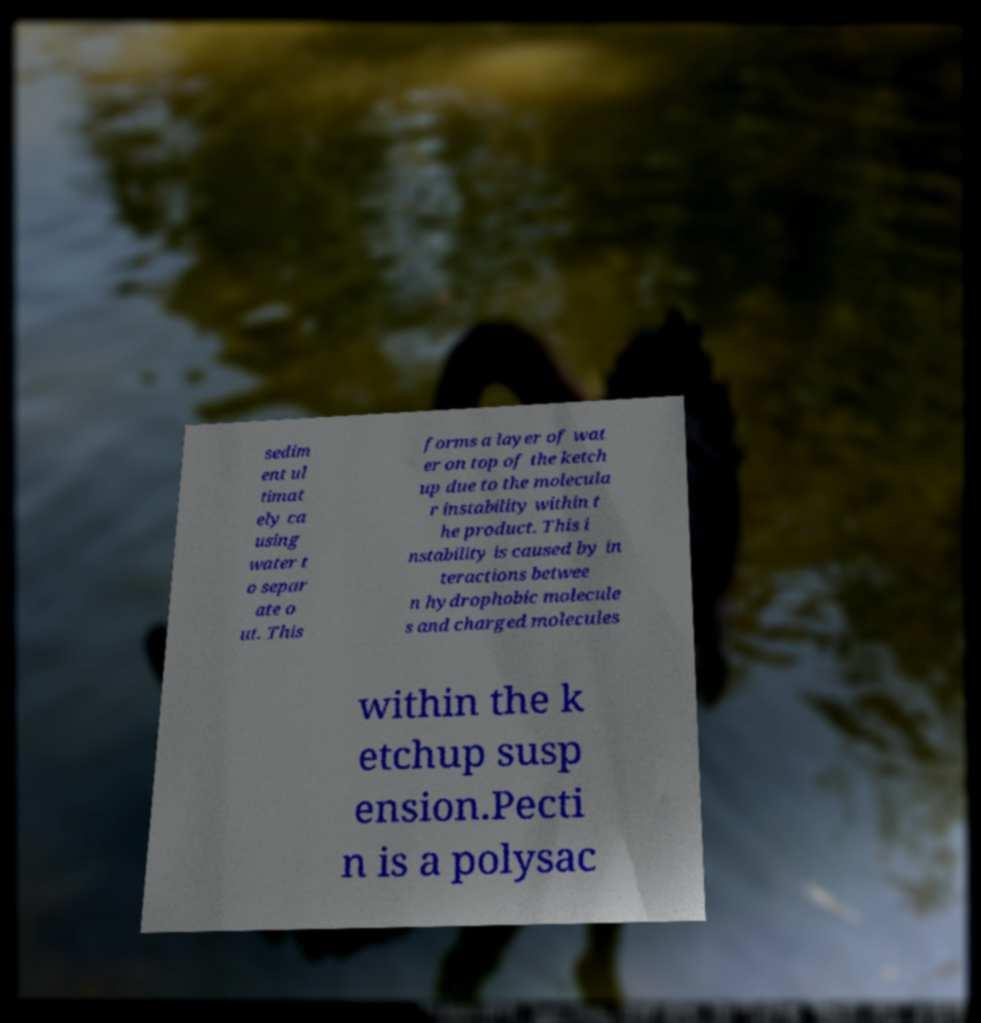Can you accurately transcribe the text from the provided image for me? sedim ent ul timat ely ca using water t o separ ate o ut. This forms a layer of wat er on top of the ketch up due to the molecula r instability within t he product. This i nstability is caused by in teractions betwee n hydrophobic molecule s and charged molecules within the k etchup susp ension.Pecti n is a polysac 